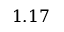Convert formula to latex. <formula><loc_0><loc_0><loc_500><loc_500>1 . 1 7</formula> 